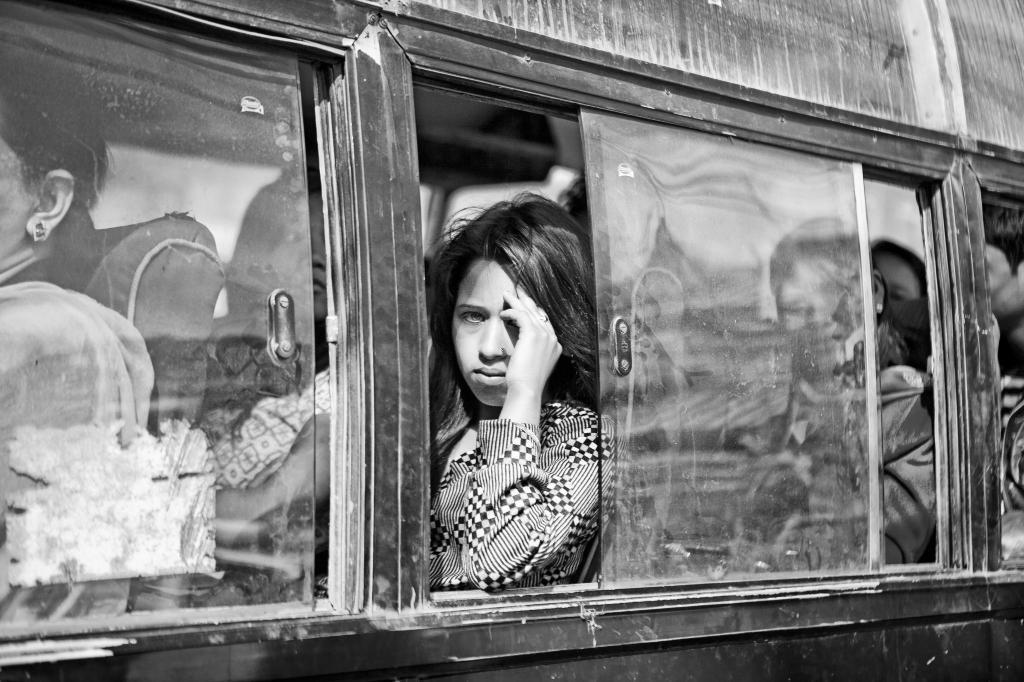In one or two sentences, can you explain what this image depicts? This looks like a black and white image. I can see few passengers sitting in the vehicle. These are the glass windows. 